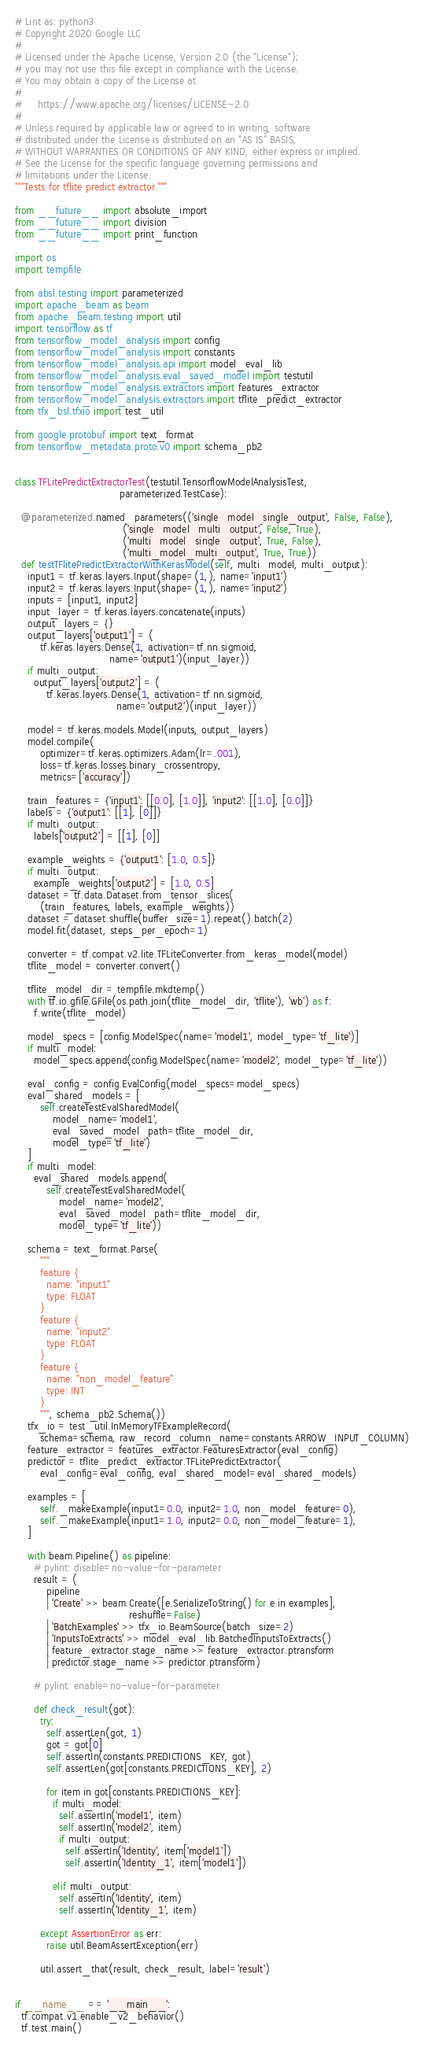Convert code to text. <code><loc_0><loc_0><loc_500><loc_500><_Python_># Lint as: python3
# Copyright 2020 Google LLC
#
# Licensed under the Apache License, Version 2.0 (the "License");
# you may not use this file except in compliance with the License.
# You may obtain a copy of the License at
#
#     https://www.apache.org/licenses/LICENSE-2.0
#
# Unless required by applicable law or agreed to in writing, software
# distributed under the License is distributed on an "AS IS" BASIS,
# WITHOUT WARRANTIES OR CONDITIONS OF ANY KIND, either express or implied.
# See the License for the specific language governing permissions and
# limitations under the License.
"""Tests for tflite predict extractor."""

from __future__ import absolute_import
from __future__ import division
from __future__ import print_function

import os
import tempfile

from absl.testing import parameterized
import apache_beam as beam
from apache_beam.testing import util
import tensorflow as tf
from tensorflow_model_analysis import config
from tensorflow_model_analysis import constants
from tensorflow_model_analysis.api import model_eval_lib
from tensorflow_model_analysis.eval_saved_model import testutil
from tensorflow_model_analysis.extractors import features_extractor
from tensorflow_model_analysis.extractors import tflite_predict_extractor
from tfx_bsl.tfxio import test_util

from google.protobuf import text_format
from tensorflow_metadata.proto.v0 import schema_pb2


class TFLitePredictExtractorTest(testutil.TensorflowModelAnalysisTest,
                                 parameterized.TestCase):

  @parameterized.named_parameters(('single_model_single_output', False, False),
                                  ('single_model_multi_output', False, True),
                                  ('multi_model_single_output', True, False),
                                  ('multi_model_multi_output', True, True))
  def testTFlitePredictExtractorWithKerasModel(self, multi_model, multi_output):
    input1 = tf.keras.layers.Input(shape=(1,), name='input1')
    input2 = tf.keras.layers.Input(shape=(1,), name='input2')
    inputs = [input1, input2]
    input_layer = tf.keras.layers.concatenate(inputs)
    output_layers = {}
    output_layers['output1'] = (
        tf.keras.layers.Dense(1, activation=tf.nn.sigmoid,
                              name='output1')(input_layer))
    if multi_output:
      output_layers['output2'] = (
          tf.keras.layers.Dense(1, activation=tf.nn.sigmoid,
                                name='output2')(input_layer))

    model = tf.keras.models.Model(inputs, output_layers)
    model.compile(
        optimizer=tf.keras.optimizers.Adam(lr=.001),
        loss=tf.keras.losses.binary_crossentropy,
        metrics=['accuracy'])

    train_features = {'input1': [[0.0], [1.0]], 'input2': [[1.0], [0.0]]}
    labels = {'output1': [[1], [0]]}
    if multi_output:
      labels['output2'] = [[1], [0]]

    example_weights = {'output1': [1.0, 0.5]}
    if multi_output:
      example_weights['output2'] = [1.0, 0.5]
    dataset = tf.data.Dataset.from_tensor_slices(
        (train_features, labels, example_weights))
    dataset = dataset.shuffle(buffer_size=1).repeat().batch(2)
    model.fit(dataset, steps_per_epoch=1)

    converter = tf.compat.v2.lite.TFLiteConverter.from_keras_model(model)
    tflite_model = converter.convert()

    tflite_model_dir = tempfile.mkdtemp()
    with tf.io.gfile.GFile(os.path.join(tflite_model_dir, 'tflite'), 'wb') as f:
      f.write(tflite_model)

    model_specs = [config.ModelSpec(name='model1', model_type='tf_lite')]
    if multi_model:
      model_specs.append(config.ModelSpec(name='model2', model_type='tf_lite'))

    eval_config = config.EvalConfig(model_specs=model_specs)
    eval_shared_models = [
        self.createTestEvalSharedModel(
            model_name='model1',
            eval_saved_model_path=tflite_model_dir,
            model_type='tf_lite')
    ]
    if multi_model:
      eval_shared_models.append(
          self.createTestEvalSharedModel(
              model_name='model2',
              eval_saved_model_path=tflite_model_dir,
              model_type='tf_lite'))

    schema = text_format.Parse(
        """
        feature {
          name: "input1"
          type: FLOAT
        }
        feature {
          name: "input2"
          type: FLOAT
        }
        feature {
          name: "non_model_feature"
          type: INT
        }
        """, schema_pb2.Schema())
    tfx_io = test_util.InMemoryTFExampleRecord(
        schema=schema, raw_record_column_name=constants.ARROW_INPUT_COLUMN)
    feature_extractor = features_extractor.FeaturesExtractor(eval_config)
    predictor = tflite_predict_extractor.TFLitePredictExtractor(
        eval_config=eval_config, eval_shared_model=eval_shared_models)

    examples = [
        self._makeExample(input1=0.0, input2=1.0, non_model_feature=0),
        self._makeExample(input1=1.0, input2=0.0, non_model_feature=1),
    ]

    with beam.Pipeline() as pipeline:
      # pylint: disable=no-value-for-parameter
      result = (
          pipeline
          | 'Create' >> beam.Create([e.SerializeToString() for e in examples],
                                    reshuffle=False)
          | 'BatchExamples' >> tfx_io.BeamSource(batch_size=2)
          | 'InputsToExtracts' >> model_eval_lib.BatchedInputsToExtracts()
          | feature_extractor.stage_name >> feature_extractor.ptransform
          | predictor.stage_name >> predictor.ptransform)

      # pylint: enable=no-value-for-parameter

      def check_result(got):
        try:
          self.assertLen(got, 1)
          got = got[0]
          self.assertIn(constants.PREDICTIONS_KEY, got)
          self.assertLen(got[constants.PREDICTIONS_KEY], 2)

          for item in got[constants.PREDICTIONS_KEY]:
            if multi_model:
              self.assertIn('model1', item)
              self.assertIn('model2', item)
              if multi_output:
                self.assertIn('Identity', item['model1'])
                self.assertIn('Identity_1', item['model1'])

            elif multi_output:
              self.assertIn('Identity', item)
              self.assertIn('Identity_1', item)

        except AssertionError as err:
          raise util.BeamAssertException(err)

        util.assert_that(result, check_result, label='result')


if __name__ == '__main__':
  tf.compat.v1.enable_v2_behavior()
  tf.test.main()
</code> 